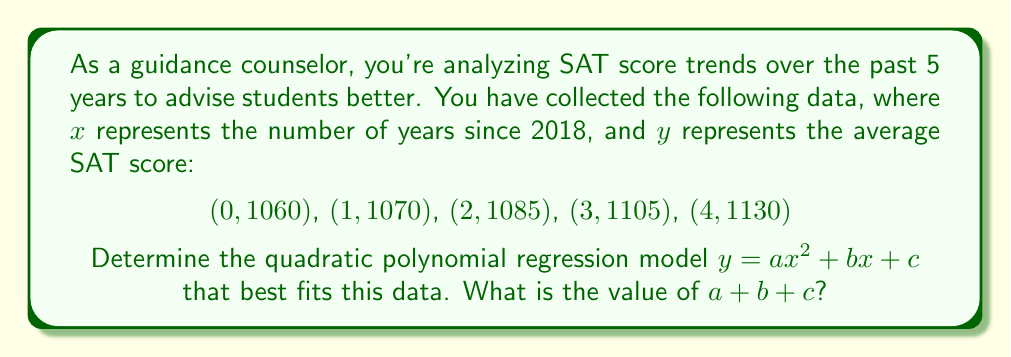Solve this math problem. To find the quadratic polynomial regression model, we'll use the method of least squares. Here are the steps:

1) We need to solve the following system of equations:

   $$\begin{cases}
   \sum y = an\sum x^2 + b\sum x + nc \\
   \sum xy = a\sum x^3 + b\sum x^2 + c\sum x \\
   \sum x^2y = a\sum x^4 + b\sum x^3 + c\sum x^2
   \end{cases}$$

2) Calculate the required sums:
   $n = 5$
   $\sum x = 0 + 1 + 2 + 3 + 4 = 10$
   $\sum x^2 = 0 + 1 + 4 + 9 + 16 = 30$
   $\sum x^3 = 0 + 1 + 8 + 27 + 64 = 100$
   $\sum x^4 = 0 + 1 + 16 + 81 + 256 = 354$
   $\sum y = 1060 + 1070 + 1085 + 1105 + 1130 = 5450$
   $\sum xy = 0 + 1070 + 2170 + 3315 + 4520 = 11075$
   $\sum x^2y = 0 + 1070 + 4340 + 9945 + 18080 = 33435$

3) Substitute these values into the system of equations:

   $$\begin{cases}
   5450 = 30a + 10b + 5c \\
   11075 = 100a + 30b + 10c \\
   33435 = 354a + 100b + 30c
   \end{cases}$$

4) Solve this system of equations (using a calculator or computer algebra system):
   $a = 2.5$
   $b = 15$
   $c = 1060$

5) Therefore, the quadratic regression model is:
   $y = 2.5x^2 + 15x + 1060$

6) The question asks for $a + b + c$:
   $2.5 + 15 + 1060 = 1077.5$
Answer: $1077.5$ 